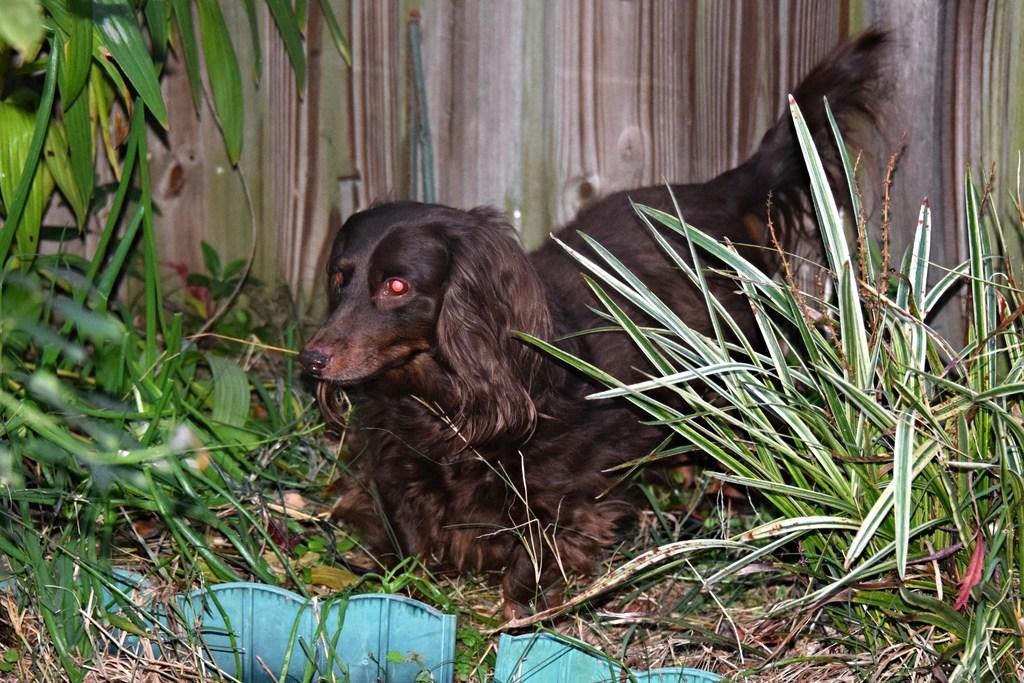Can you describe this image briefly? In the image there is a dog standing in front of fence, on either side of it there are plants on the land. 